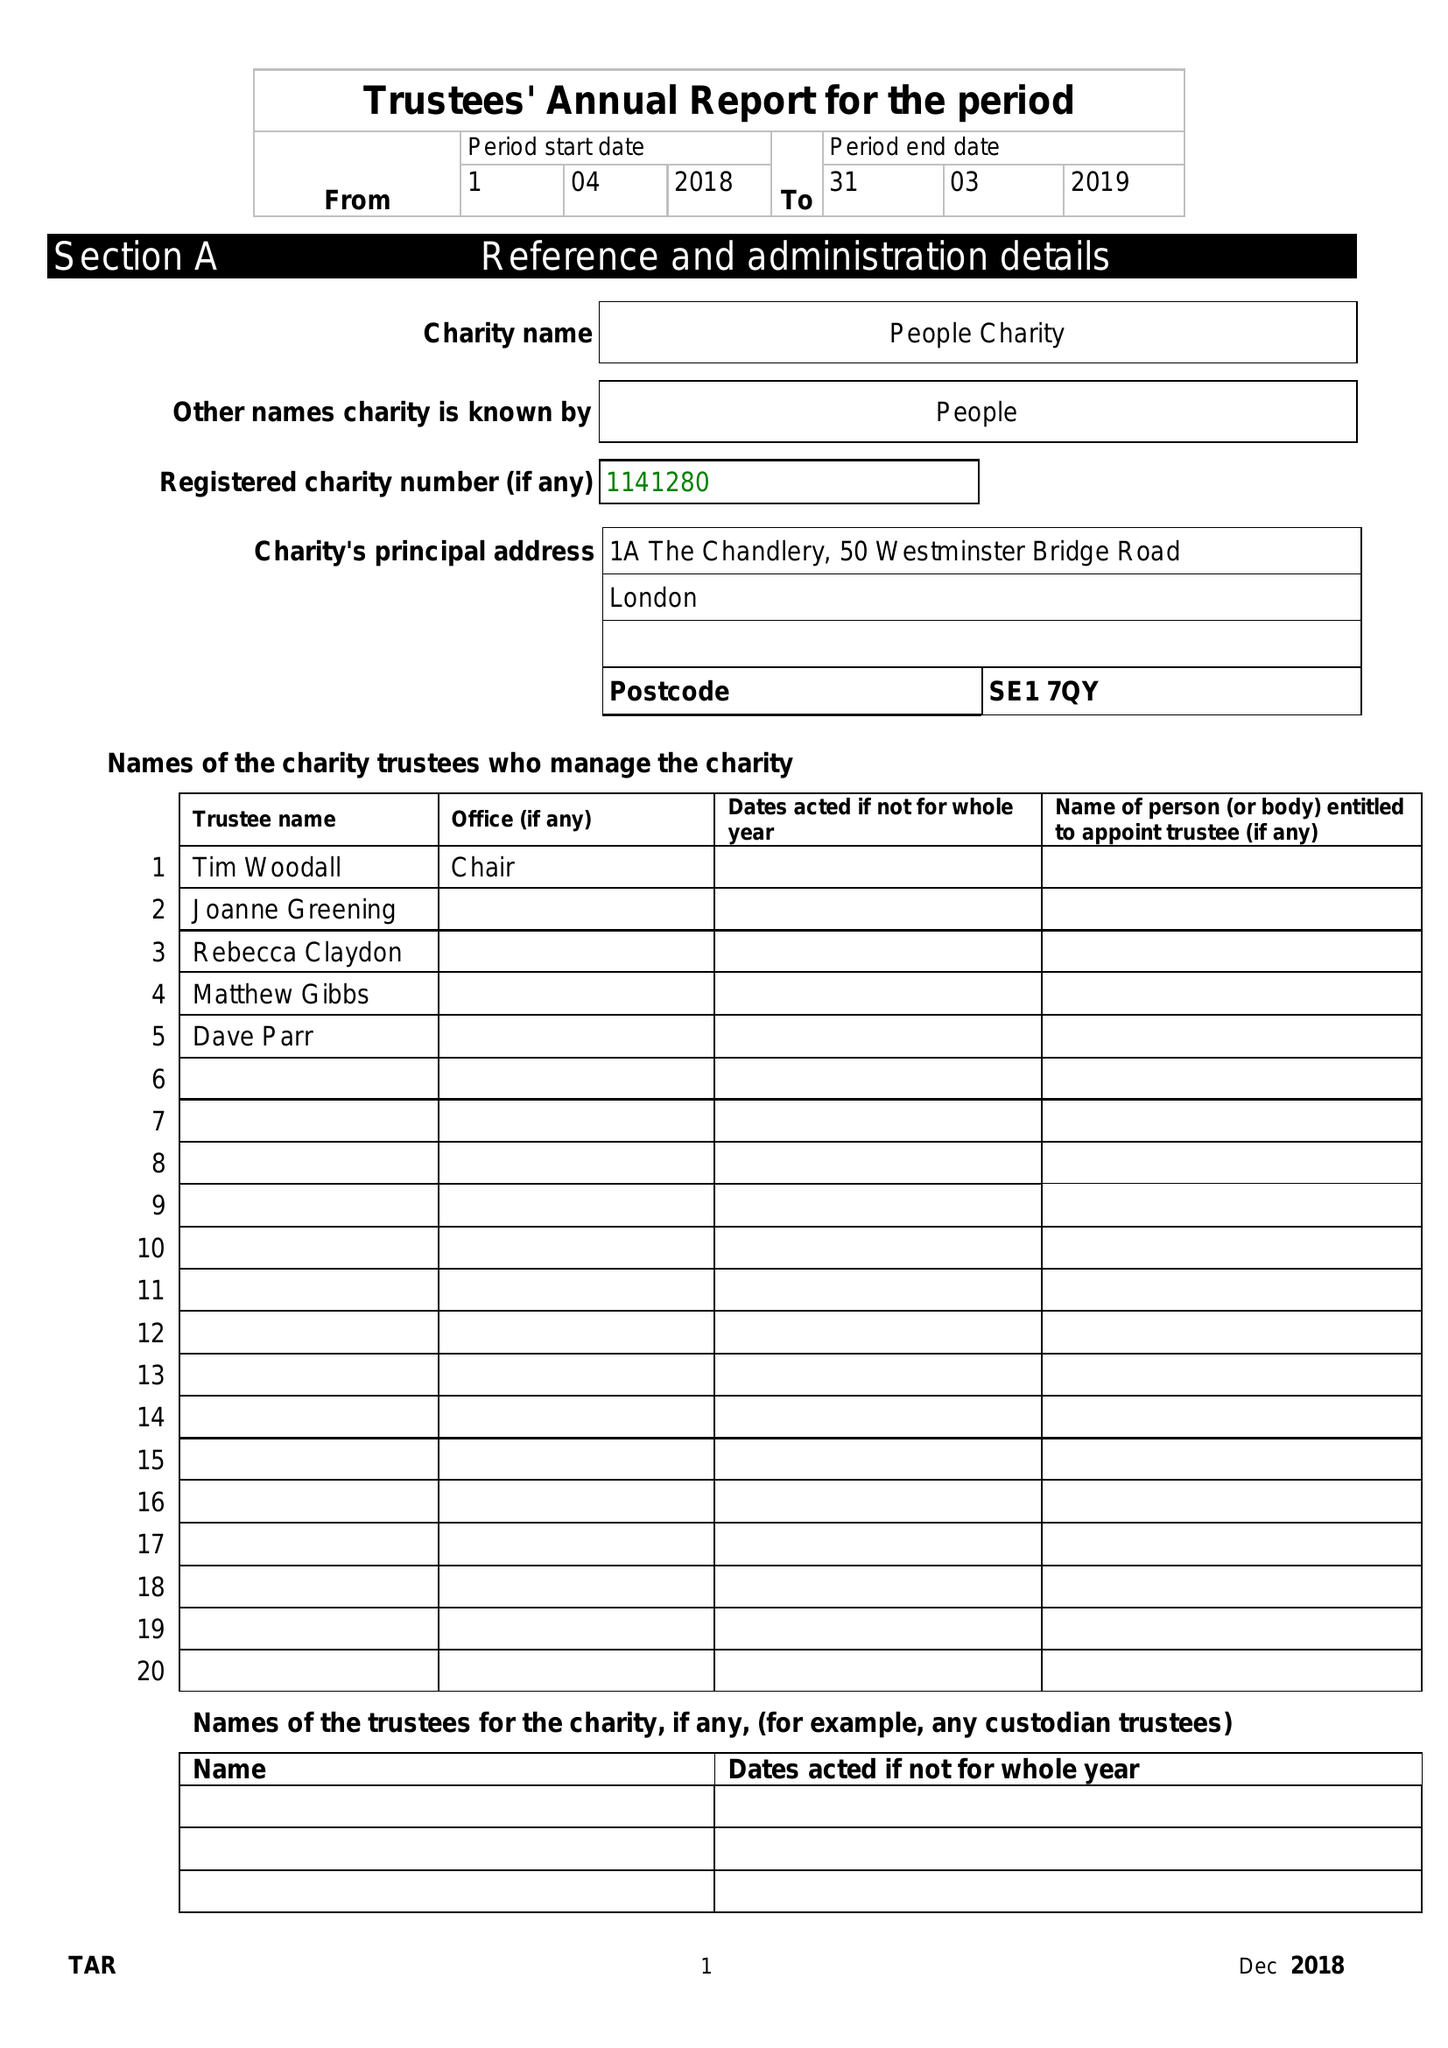What is the value for the charity_name?
Answer the question using a single word or phrase. People Charity 